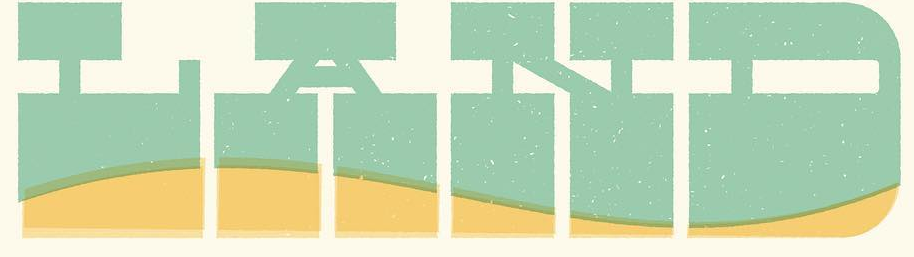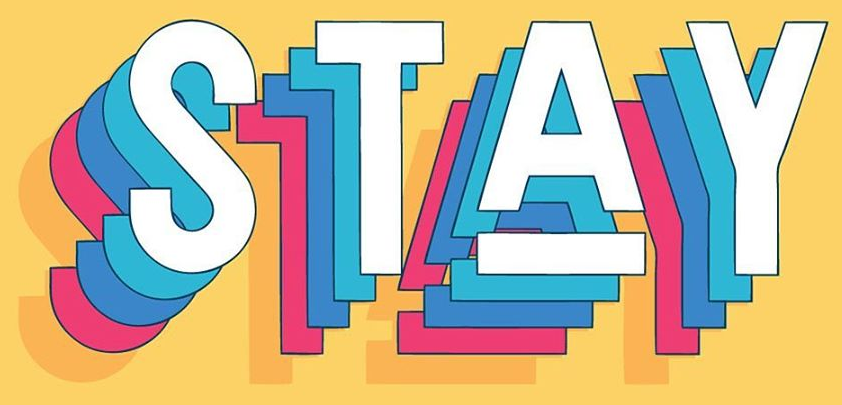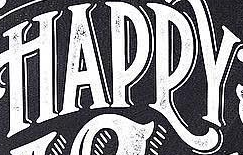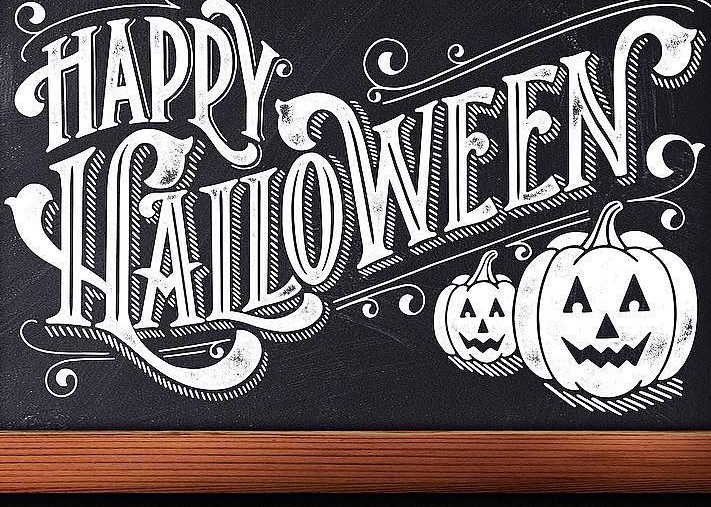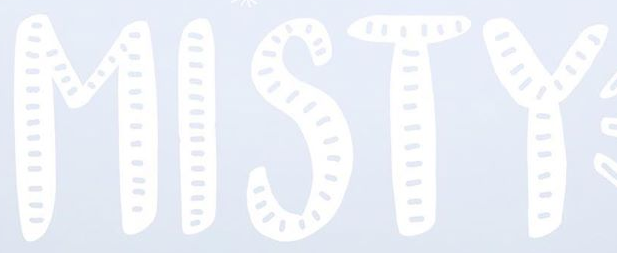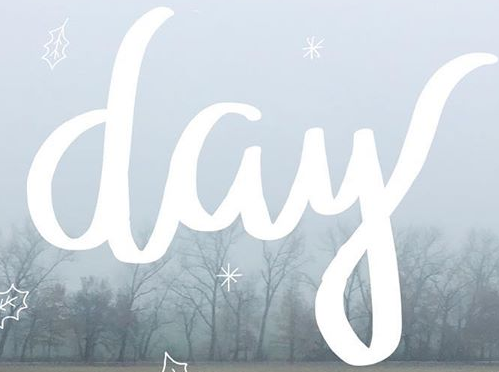What text appears in these images from left to right, separated by a semicolon? LAND; STAY; HAPPY; HALLOWEEN; MISTY; day 